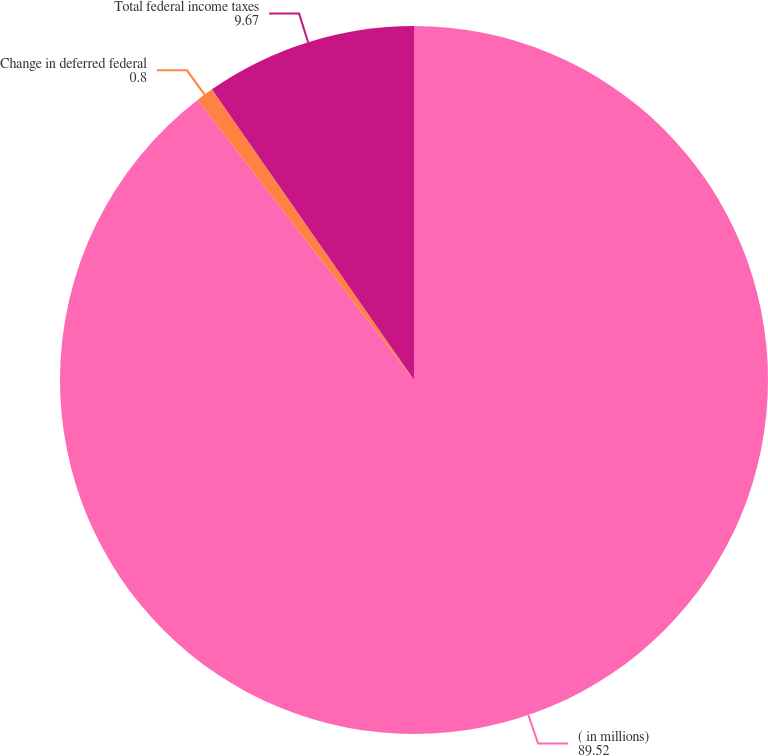Convert chart. <chart><loc_0><loc_0><loc_500><loc_500><pie_chart><fcel>( in millions)<fcel>Change in deferred federal<fcel>Total federal income taxes<nl><fcel>89.52%<fcel>0.8%<fcel>9.67%<nl></chart> 